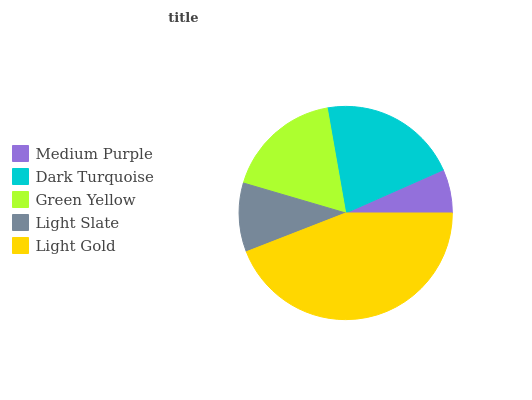Is Medium Purple the minimum?
Answer yes or no. Yes. Is Light Gold the maximum?
Answer yes or no. Yes. Is Dark Turquoise the minimum?
Answer yes or no. No. Is Dark Turquoise the maximum?
Answer yes or no. No. Is Dark Turquoise greater than Medium Purple?
Answer yes or no. Yes. Is Medium Purple less than Dark Turquoise?
Answer yes or no. Yes. Is Medium Purple greater than Dark Turquoise?
Answer yes or no. No. Is Dark Turquoise less than Medium Purple?
Answer yes or no. No. Is Green Yellow the high median?
Answer yes or no. Yes. Is Green Yellow the low median?
Answer yes or no. Yes. Is Medium Purple the high median?
Answer yes or no. No. Is Medium Purple the low median?
Answer yes or no. No. 